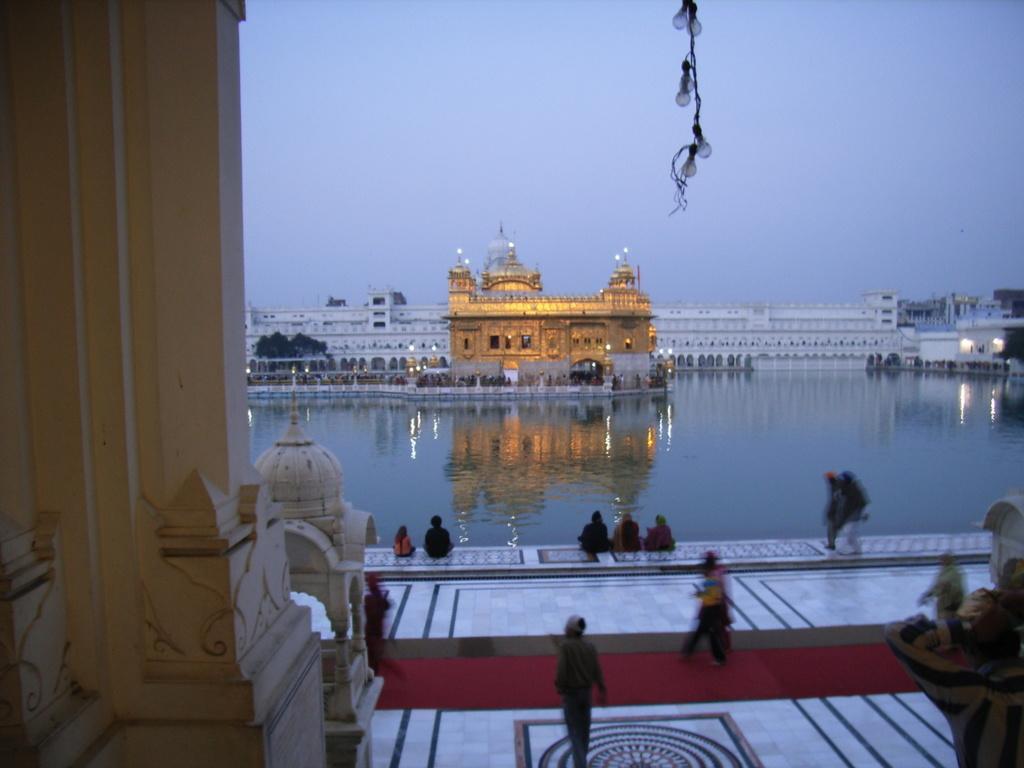Please provide a concise description of this image. In the foreground of this image, there are few people walking and sitting on the floor. On the left, it seems like a pillar and also there is an object on the right. In the background, there is water and we can also see buildings and the sky and few bulbs at the top. 